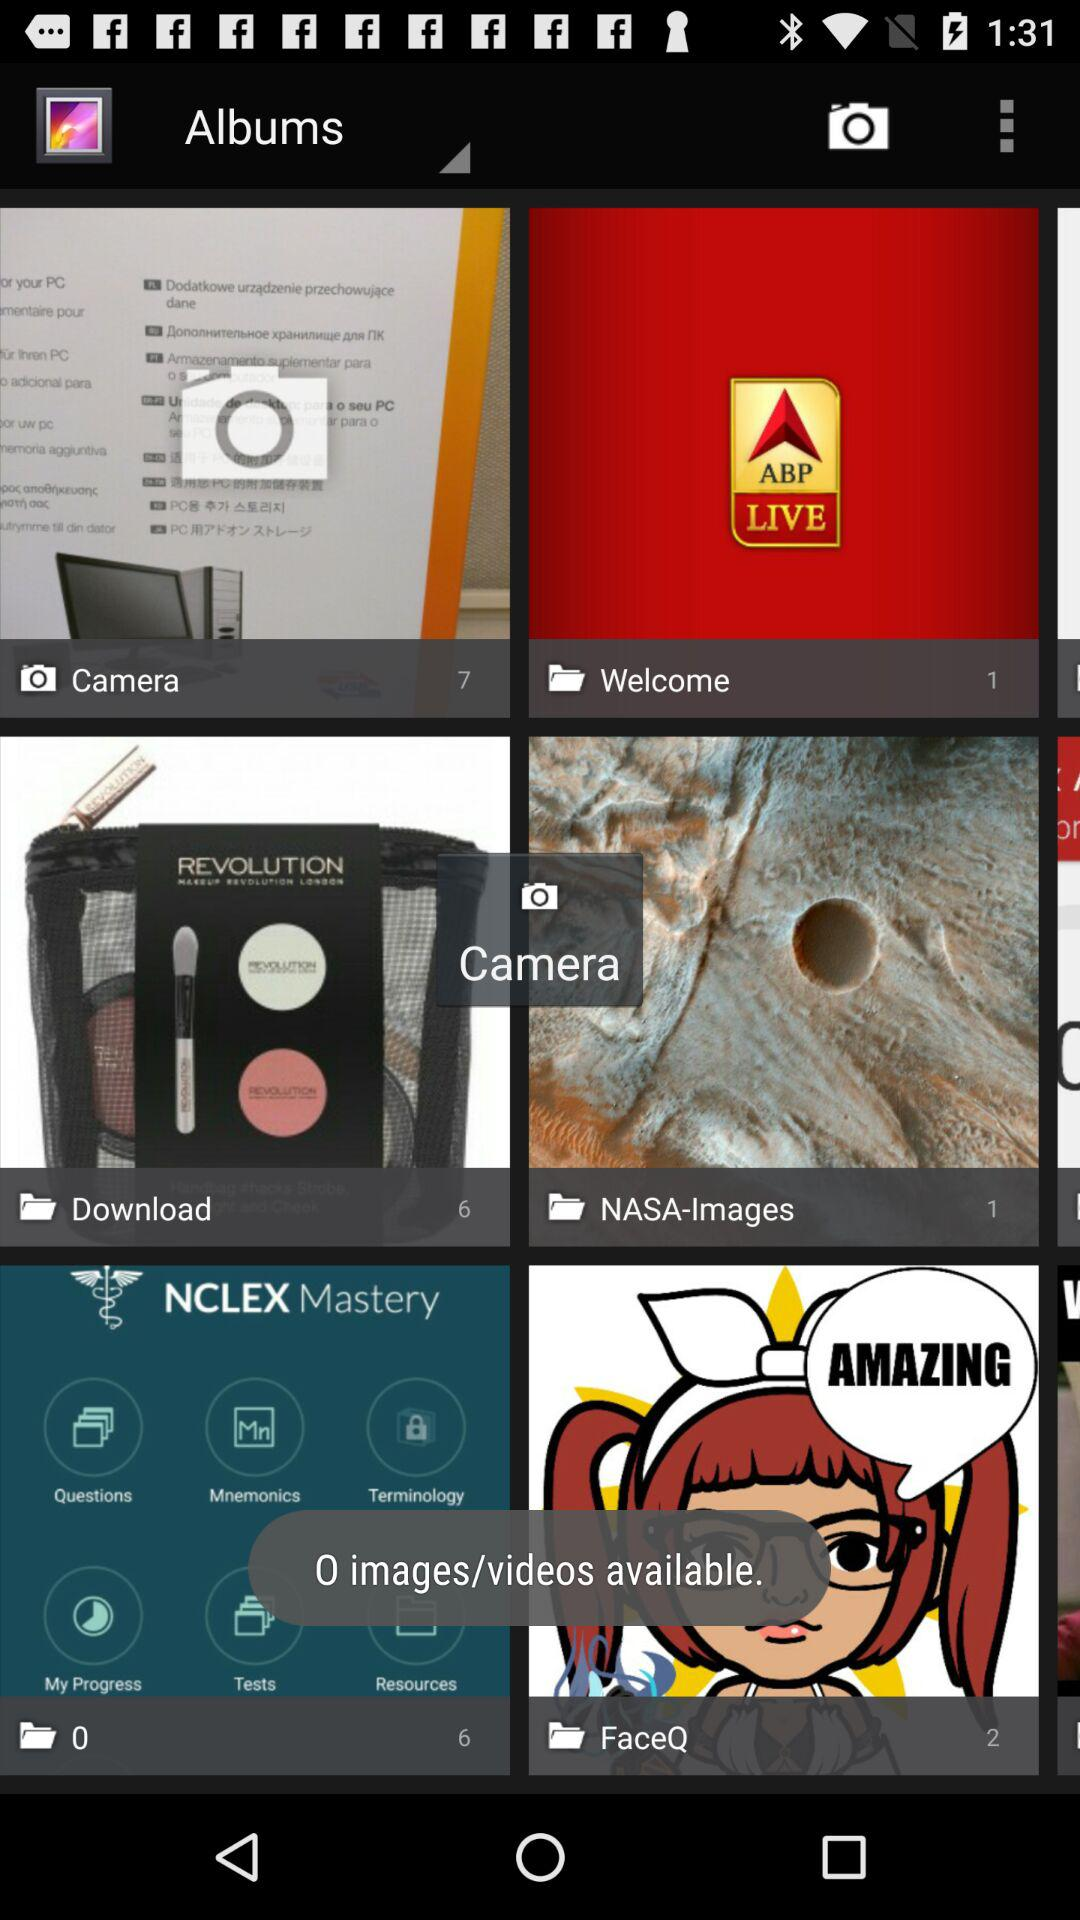Which album was selected?
When the provided information is insufficient, respond with <no answer>. <no answer> 